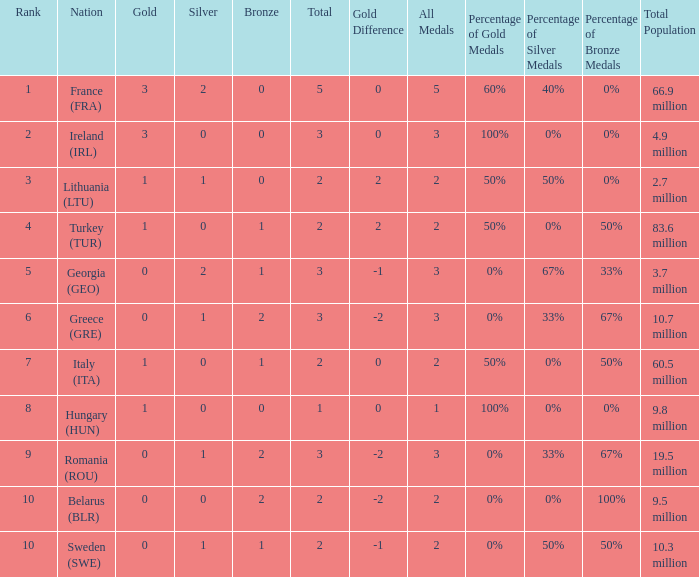What's the total number of bronze medals for Sweden (SWE) having less than 1 gold and silver? 0.0. 